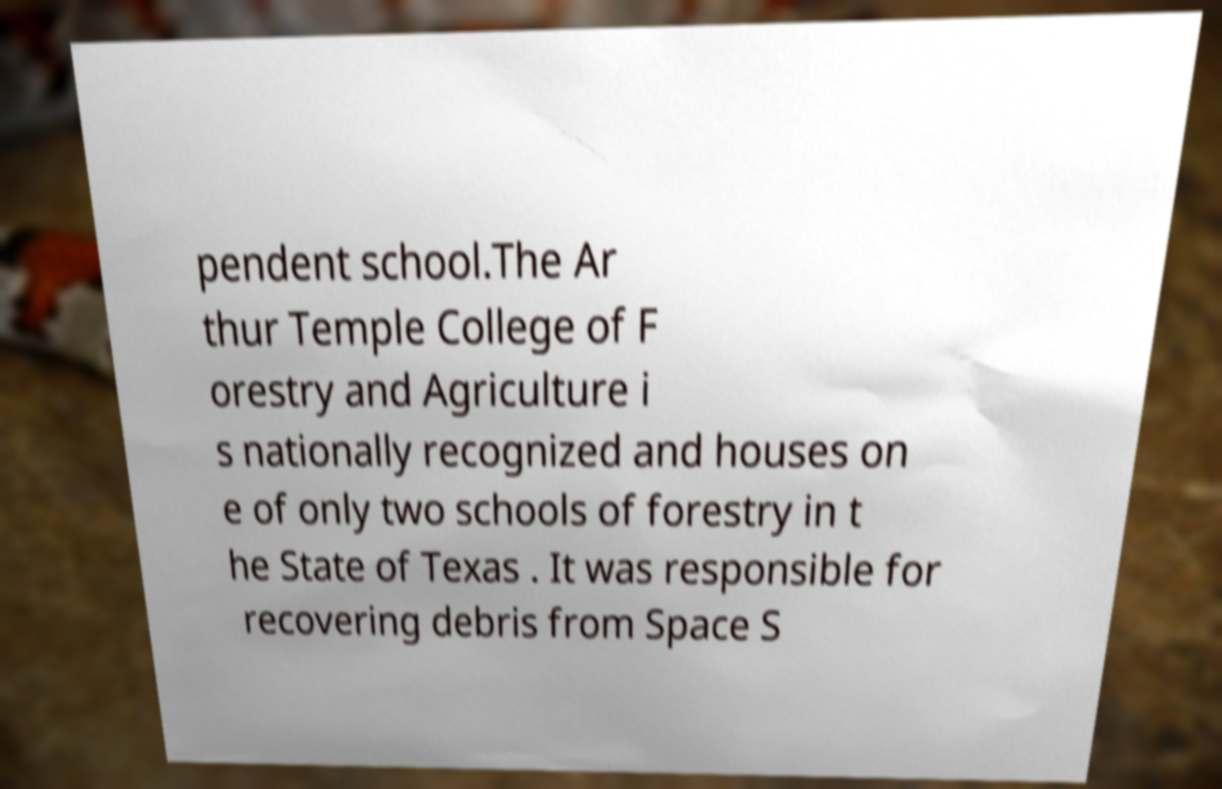Can you accurately transcribe the text from the provided image for me? pendent school.The Ar thur Temple College of F orestry and Agriculture i s nationally recognized and houses on e of only two schools of forestry in t he State of Texas . It was responsible for recovering debris from Space S 